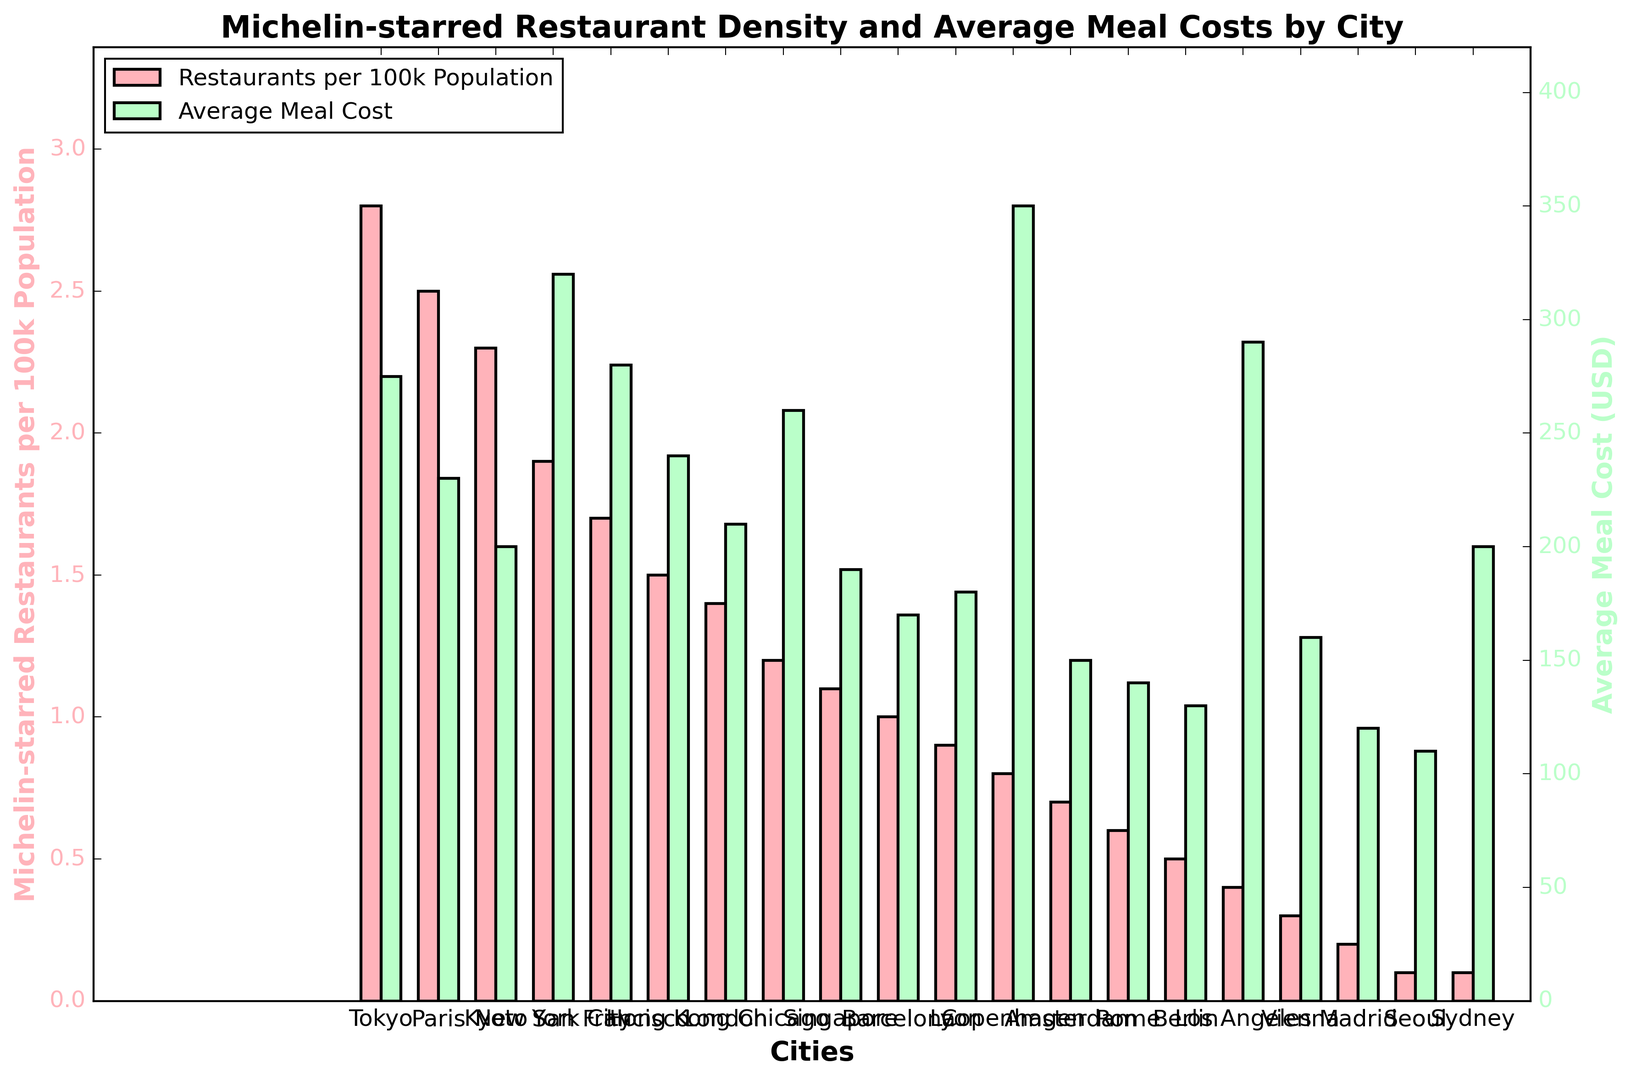Which city has the highest density of Michelin-starred restaurants? Tokyo has the highest red-colored bar representing Michelin-starred restaurants per 100k population.
Answer: Tokyo Which city has the highest average meal cost? Copenhagen has the highest green-colored bar representing the average meal cost in USD.
Answer: Copenhagen How much higher is the average meal cost in New York City compared to Paris? New York City has a meal cost bar at 320 USD and Paris at 230 USD. The difference is 320 - 230 = 90 USD.
Answer: 90 USD Which city has the smallest density of Michelin-starred restaurants, and what is its corresponding average meal cost? Both Seoul and Sydney have the smallest red-colored bars for Michelin-starred restaurant density, with a corresponding green-colored bar indicating an average meal cost of 110 USD for Seoul and 200 USD for Sydney.
Answer: Seoul, 110 USD and Sydney, 200 USD Which city has a higher density of Michelin-starred restaurants: London or Barcelona? London's red-colored bar is slightly higher than Barcelona's, indicating a higher density of Michelin-starred restaurants.
Answer: London Which city has the green bar representing an average meal cost above the red bar representing Michelin-starred restaurants density, but below 300 USD? San Francisco has a green bar representing an average meal cost above the red bar for Michelin-starred restaurants density, yet below 300 USD.
Answer: San Francisco Which two cities have the closest Michelin-starred restaurant densities, and what are their densities? Singapore and Barcelona have Michelin-starred restaurant densities that are very close in height, with both around 1.0 and 1.1 per 100k population, respectively.
Answer: Singapore (1.1), Barcelona (1.0) How does the average meal cost in Tokyo compare to Hong Kong? The green bar for Tokyo (275 USD) is higher than the corresponding bar for Hong Kong (240 USD).
Answer: Higher 